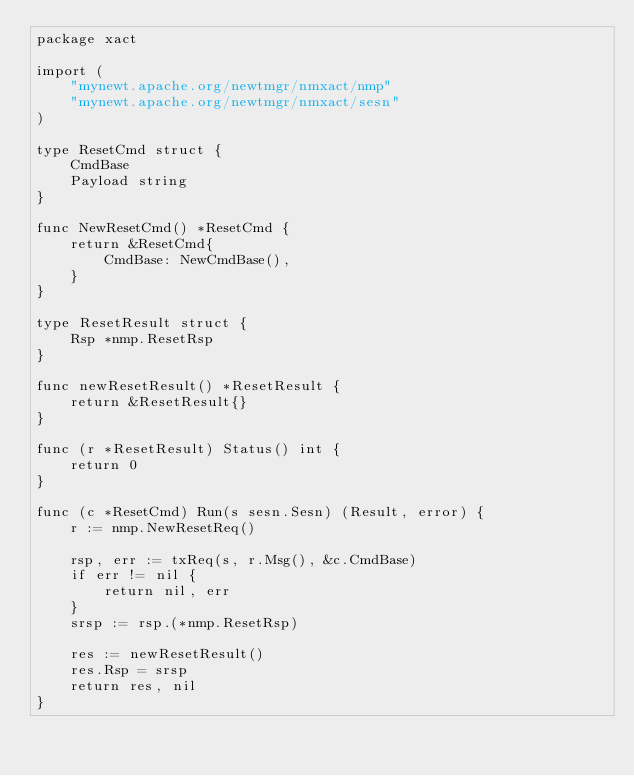<code> <loc_0><loc_0><loc_500><loc_500><_Go_>package xact

import (
	"mynewt.apache.org/newtmgr/nmxact/nmp"
	"mynewt.apache.org/newtmgr/nmxact/sesn"
)

type ResetCmd struct {
	CmdBase
	Payload string
}

func NewResetCmd() *ResetCmd {
	return &ResetCmd{
		CmdBase: NewCmdBase(),
	}
}

type ResetResult struct {
	Rsp *nmp.ResetRsp
}

func newResetResult() *ResetResult {
	return &ResetResult{}
}

func (r *ResetResult) Status() int {
	return 0
}

func (c *ResetCmd) Run(s sesn.Sesn) (Result, error) {
	r := nmp.NewResetReq()

	rsp, err := txReq(s, r.Msg(), &c.CmdBase)
	if err != nil {
		return nil, err
	}
	srsp := rsp.(*nmp.ResetRsp)

	res := newResetResult()
	res.Rsp = srsp
	return res, nil
}
</code> 